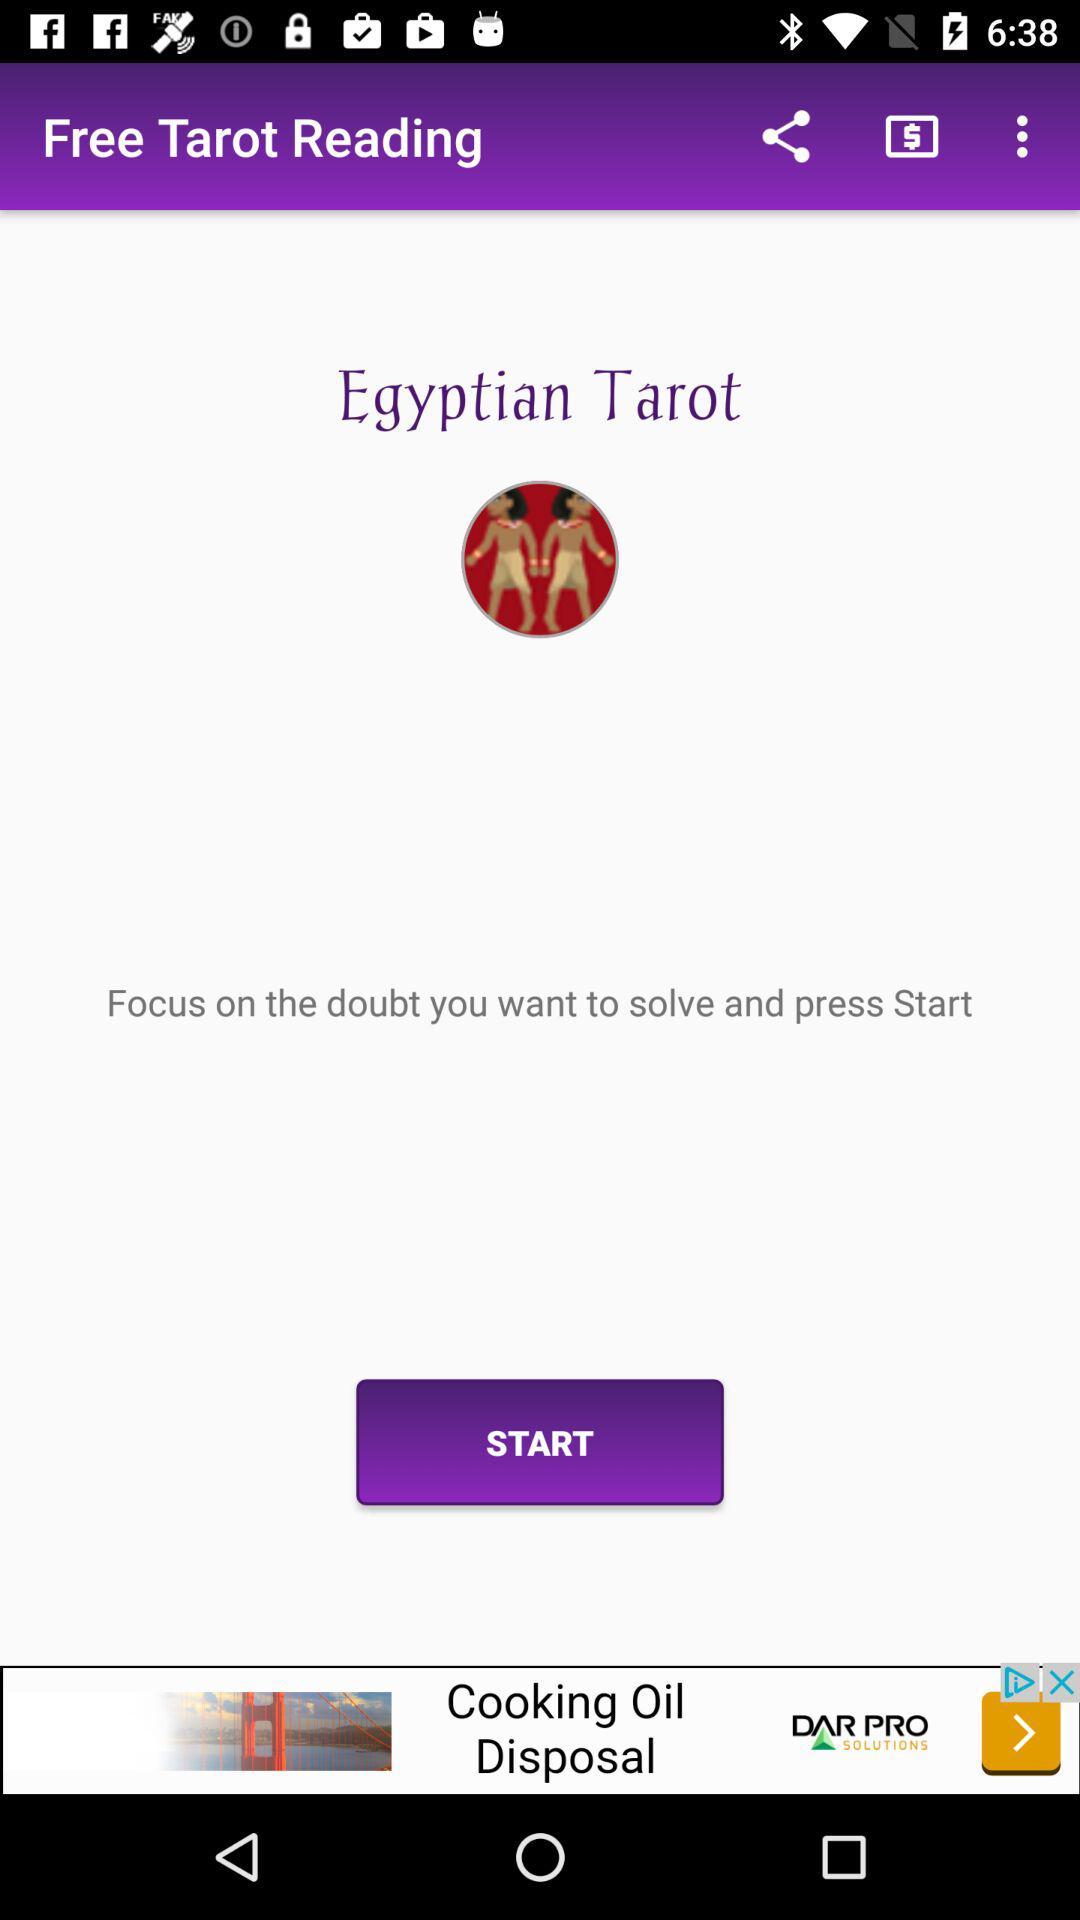What is the application name? The application is "Free Tarot Reading". 